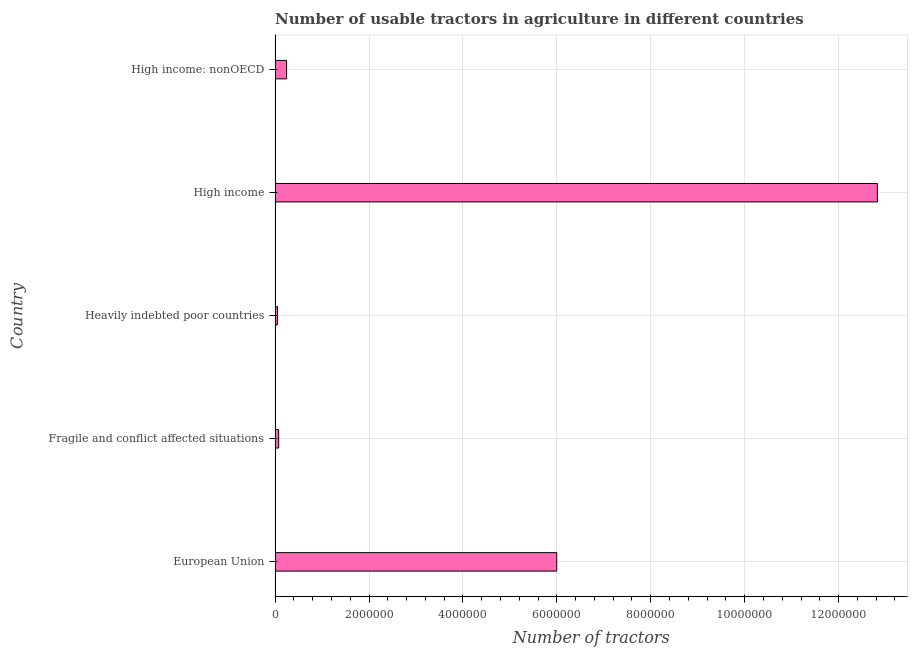Does the graph contain any zero values?
Your answer should be compact. No. Does the graph contain grids?
Ensure brevity in your answer.  Yes. What is the title of the graph?
Give a very brief answer. Number of usable tractors in agriculture in different countries. What is the label or title of the X-axis?
Give a very brief answer. Number of tractors. What is the label or title of the Y-axis?
Keep it short and to the point. Country. What is the number of tractors in High income: nonOECD?
Your answer should be compact. 2.45e+05. Across all countries, what is the maximum number of tractors?
Offer a terse response. 1.28e+07. Across all countries, what is the minimum number of tractors?
Your answer should be very brief. 5.03e+04. In which country was the number of tractors minimum?
Make the answer very short. Heavily indebted poor countries. What is the sum of the number of tractors?
Keep it short and to the point. 1.92e+07. What is the difference between the number of tractors in Fragile and conflict affected situations and High income?
Give a very brief answer. -1.27e+07. What is the average number of tractors per country?
Your answer should be compact. 3.84e+06. What is the median number of tractors?
Offer a very short reply. 2.45e+05. What is the ratio of the number of tractors in European Union to that in Heavily indebted poor countries?
Your response must be concise. 119.34. What is the difference between the highest and the second highest number of tractors?
Offer a terse response. 6.83e+06. What is the difference between the highest and the lowest number of tractors?
Give a very brief answer. 1.28e+07. How many bars are there?
Give a very brief answer. 5. Are all the bars in the graph horizontal?
Provide a succinct answer. Yes. Are the values on the major ticks of X-axis written in scientific E-notation?
Offer a terse response. No. What is the Number of tractors in European Union?
Your response must be concise. 6.00e+06. What is the Number of tractors of Fragile and conflict affected situations?
Give a very brief answer. 7.65e+04. What is the Number of tractors of Heavily indebted poor countries?
Your answer should be very brief. 5.03e+04. What is the Number of tractors of High income?
Keep it short and to the point. 1.28e+07. What is the Number of tractors of High income: nonOECD?
Keep it short and to the point. 2.45e+05. What is the difference between the Number of tractors in European Union and Fragile and conflict affected situations?
Your answer should be very brief. 5.92e+06. What is the difference between the Number of tractors in European Union and Heavily indebted poor countries?
Ensure brevity in your answer.  5.95e+06. What is the difference between the Number of tractors in European Union and High income?
Offer a very short reply. -6.83e+06. What is the difference between the Number of tractors in European Union and High income: nonOECD?
Your response must be concise. 5.75e+06. What is the difference between the Number of tractors in Fragile and conflict affected situations and Heavily indebted poor countries?
Provide a succinct answer. 2.63e+04. What is the difference between the Number of tractors in Fragile and conflict affected situations and High income?
Offer a very short reply. -1.27e+07. What is the difference between the Number of tractors in Fragile and conflict affected situations and High income: nonOECD?
Make the answer very short. -1.69e+05. What is the difference between the Number of tractors in Heavily indebted poor countries and High income?
Your response must be concise. -1.28e+07. What is the difference between the Number of tractors in Heavily indebted poor countries and High income: nonOECD?
Offer a very short reply. -1.95e+05. What is the difference between the Number of tractors in High income and High income: nonOECD?
Your response must be concise. 1.26e+07. What is the ratio of the Number of tractors in European Union to that in Fragile and conflict affected situations?
Give a very brief answer. 78.36. What is the ratio of the Number of tractors in European Union to that in Heavily indebted poor countries?
Provide a short and direct response. 119.34. What is the ratio of the Number of tractors in European Union to that in High income?
Offer a terse response. 0.47. What is the ratio of the Number of tractors in European Union to that in High income: nonOECD?
Offer a very short reply. 24.46. What is the ratio of the Number of tractors in Fragile and conflict affected situations to that in Heavily indebted poor countries?
Offer a terse response. 1.52. What is the ratio of the Number of tractors in Fragile and conflict affected situations to that in High income?
Provide a short and direct response. 0.01. What is the ratio of the Number of tractors in Fragile and conflict affected situations to that in High income: nonOECD?
Make the answer very short. 0.31. What is the ratio of the Number of tractors in Heavily indebted poor countries to that in High income?
Ensure brevity in your answer.  0. What is the ratio of the Number of tractors in Heavily indebted poor countries to that in High income: nonOECD?
Make the answer very short. 0.2. What is the ratio of the Number of tractors in High income to that in High income: nonOECD?
Keep it short and to the point. 52.31. 